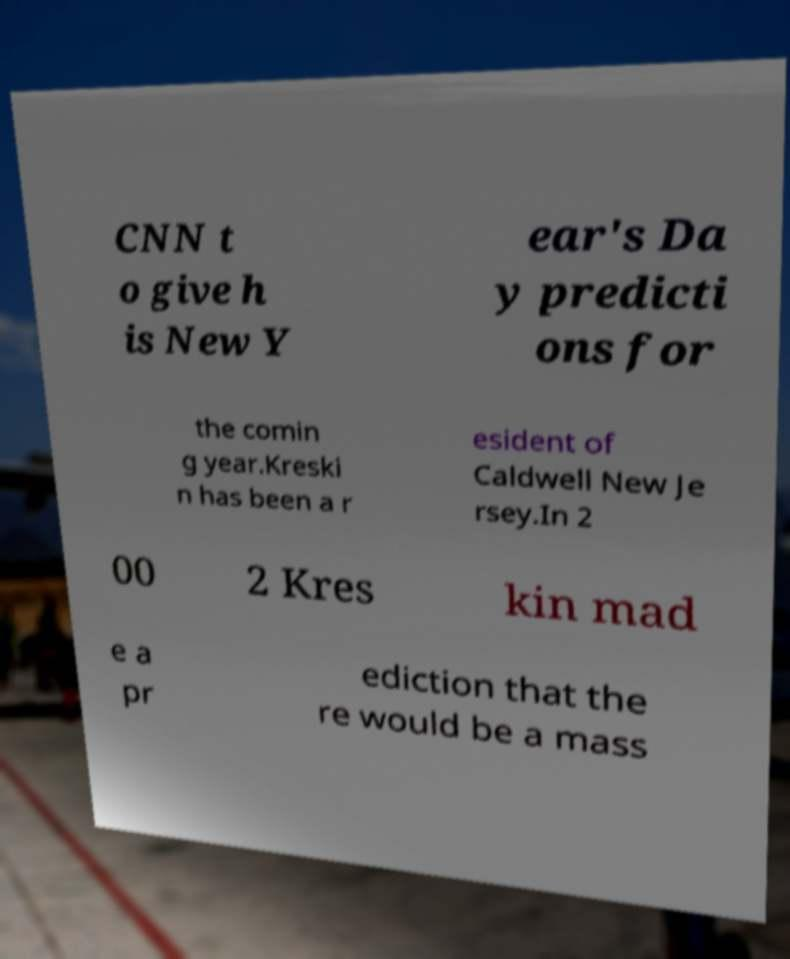Can you read and provide the text displayed in the image?This photo seems to have some interesting text. Can you extract and type it out for me? CNN t o give h is New Y ear's Da y predicti ons for the comin g year.Kreski n has been a r esident of Caldwell New Je rsey.In 2 00 2 Kres kin mad e a pr ediction that the re would be a mass 